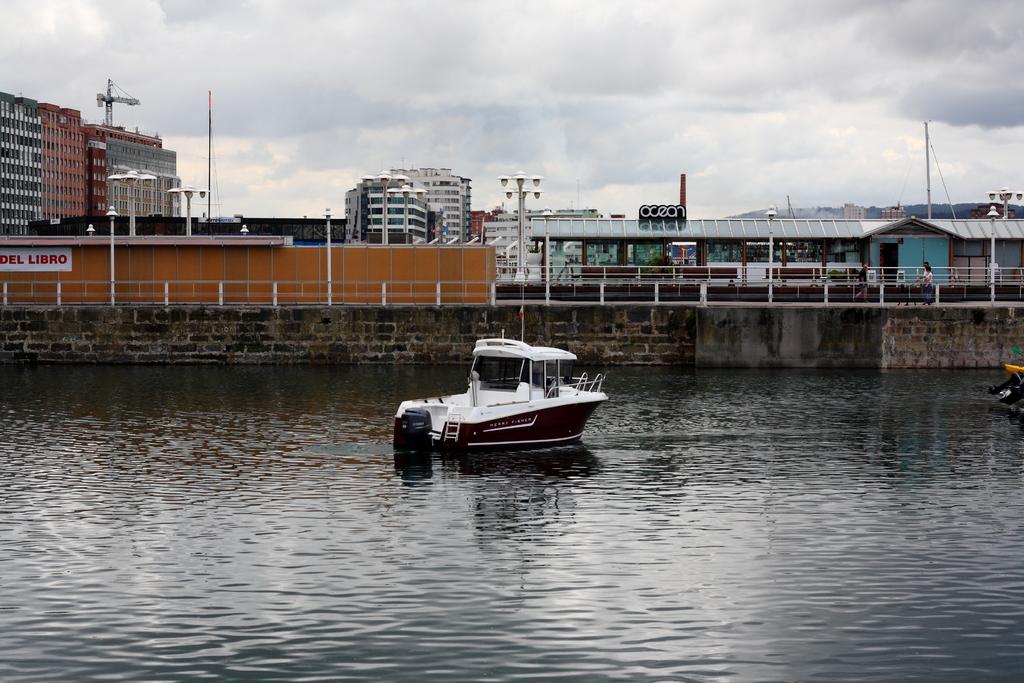What is on the sign in the distance?
Make the answer very short. Del libro. 